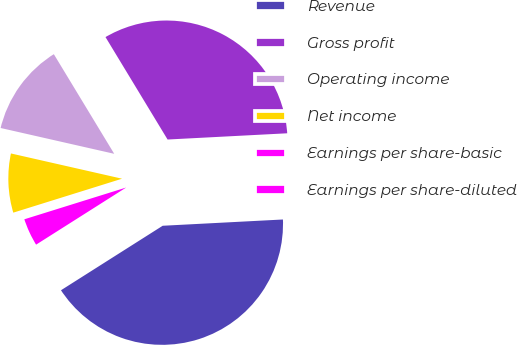Convert chart. <chart><loc_0><loc_0><loc_500><loc_500><pie_chart><fcel>Revenue<fcel>Gross profit<fcel>Operating income<fcel>Net income<fcel>Earnings per share-basic<fcel>Earnings per share-diluted<nl><fcel>41.83%<fcel>32.84%<fcel>12.77%<fcel>8.37%<fcel>4.18%<fcel>0.0%<nl></chart> 